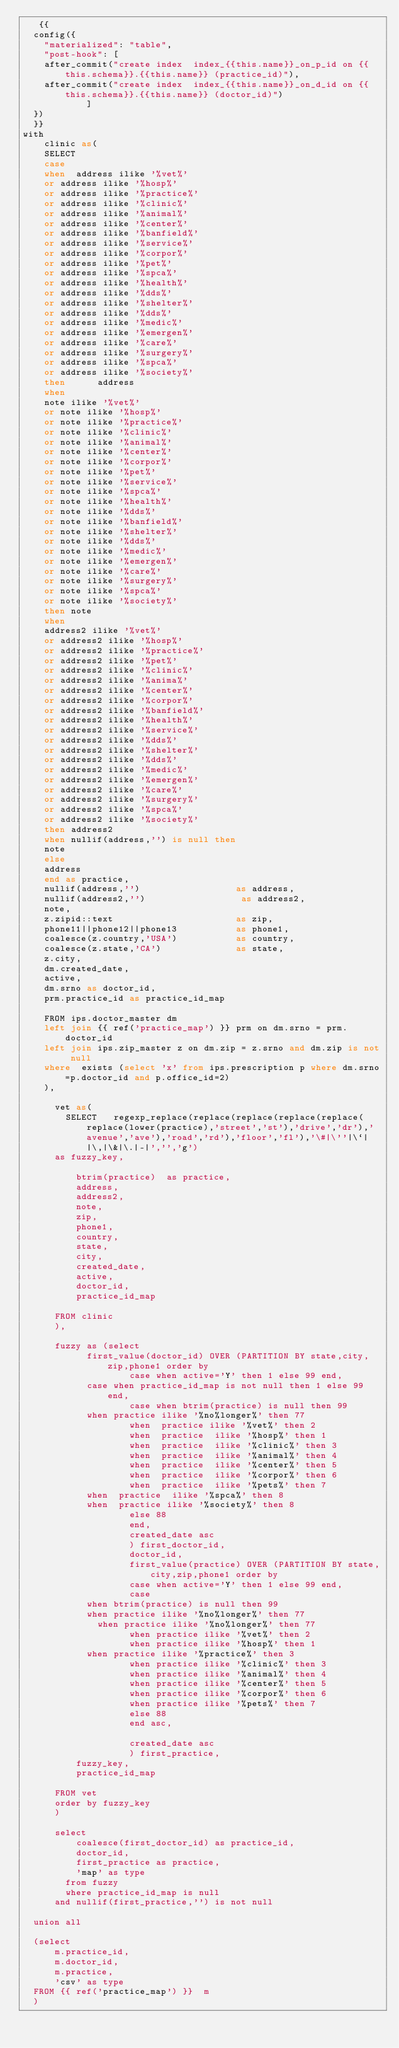Convert code to text. <code><loc_0><loc_0><loc_500><loc_500><_SQL_>   {{
  config({
    "materialized": "table",
    "post-hook": [
    after_commit("create index  index_{{this.name}}_on_p_id on {{this.schema}}.{{this.name}} (practice_id)"),
    after_commit("create index  index_{{this.name}}_on_d_id on {{this.schema}}.{{this.name}} (doctor_id)")
            ]
  })
  }}
with
    clinic as( 
    SELECT 
    case 
    when  address ilike '%vet%'
    or address ilike '%hosp%' 
    or address ilike '%practice%' 
    or address ilike '%clinic%' 
    or address ilike '%animal%'
    or address ilike '%center%' 
    or address ilike '%banfield%' 
    or address ilike '%service%' 
    or address ilike '%corpor%' 
    or address ilike '%pet%' 
    or address ilike '%spca%' 
    or address ilike '%health%' 
    or address ilike '%dds%' 
    or address ilike '%shelter%' 
    or address ilike '%dds%' 
    or address ilike '%medic%' 
    or address ilike '%emergen%' 
    or address ilike '%care%' 
    or address ilike '%surgery%' 
    or address ilike '%spca%' 
    or address ilike '%society%' 
    then      address
    when 		   
    note ilike '%vet%'
    or note ilike '%hosp%' 
    or note ilike '%practice%' 
    or note ilike '%clinic%' 
    or note ilike '%animal%'
    or note ilike '%center%' 
    or note ilike '%corpor%' 
    or note ilike '%pet%' 
    or note ilike '%service%' 
    or note ilike '%spca%' 	  
    or note ilike '%health%' 
    or note ilike '%dds%' 
    or note ilike '%banfield%' 
    or note ilike '%shelter%' 
    or note ilike '%dds%' 
    or note ilike '%medic%' 
    or note ilike '%emergen%' 
    or note ilike '%care%' 
    or note ilike '%surgery%' 
    or note ilike '%spca%' 
    or note ilike '%society%' 
    then note
    when 
    address2 ilike '%vet%'
    or address2 ilike '%hosp%' 
    or address2 ilike '%practice%' 
    or address2 ilike '%pet%' 
    or address2 ilike '%clinic%' 
    or address2 ilike '%anima%'
    or address2 ilike '%center%' 
    or address2 ilike '%corpor%' 
    or address2 ilike '%banfield%' 
    or address2 ilike '%health%' 
    or address2 ilike '%service%' 
    or address2 ilike '%dds%' 
    or address2 ilike '%shelter%' 
    or address2 ilike '%dds%' 
    or address2 ilike '%medic%' 
    or address2 ilike '%emergen%' 
    or address2 ilike '%care%' 
    or address2 ilike '%surgery%' 
    or address2 ilike '%spca%' 
    or address2 ilike '%society%' 
    then address2
    when nullif(address,'') is null then
    note
    else
    address
    end as practice,
    nullif(address,'')                  as address,
    nullif(address2,'')                  as address2,
    note,
    z.zipid::text                       as zip,
    phone11||phone12||phone13           as phone1,
    coalesce(z.country,'USA')           as country,
    coalesce(z.state,'CA')              as state,
    z.city,
    dm.created_date,
    active,
    dm.srno as doctor_id,
    prm.practice_id as practice_id_map

    FROM ips.doctor_master dm
    left join {{ ref('practice_map') }} prm on dm.srno = prm.doctor_id
    left join ips.zip_master z on dm.zip = z.srno and dm.zip is not null
    where  exists (select 'x' from ips.prescription p where dm.srno=p.doctor_id and p.office_id=2)
    ), 

      vet as(
        SELECT   regexp_replace(replace(replace(replace(replace(replace(lower(practice),'street','st'),'drive','dr'),'avenue','ave'),'road','rd'),'floor','fl'),'\#|\''|\`| |\,|\&|\.|-|','','g')
      as fuzzy_key,   

          btrim(practice)  as practice,
          address,
          address2,
          note,
          zip,
          phone1,
          country,
          state,
          city,
          created_date,
          active,
          doctor_id,	   
          practice_id_map

      FROM clinic
      ),
      
      fuzzy as (select 
            first_value(doctor_id) OVER (PARTITION BY state,city,zip,phone1 order by 
                    case when active='Y' then 1 else 99 end,   
            case when practice_id_map is not null then 1 else 99 end,
                    case when btrim(practice) is null then 99
            when practice ilike '%no%longer%' then 77
                    when  practice ilike '%vet%' then 2
                    when  practice  ilike '%hosp%' then 1 
                    when  practice  ilike '%clinic%' then 3
                    when  practice  ilike '%animal%' then 4
                    when  practice  ilike '%center%' then 5
                    when  practice  ilike '%corpor%' then 6
                    when  practice  ilike '%pets%' then 7
            when  practice  ilike '%spca%' then 8
            when  practice ilike '%society%' then 8
                    else 88
                    end,             
                    created_date asc               
                    ) first_doctor_id,	
                    doctor_id,
                    first_value(practice) OVER (PARTITION BY state,city,zip,phone1 order by 
                    case when active='Y' then 1 else 99 end,
                    case 
            when btrim(practice) is null then 99
            when practice ilike '%no%longer%' then 77
              when practice ilike '%no%longer%' then 77
                    when practice ilike '%vet%' then 2
                    when practice ilike '%hosp%' then 1 
            when practice ilike '%practice%' then 3 
                    when practice ilike '%clinic%' then 3
                    when practice ilike '%animal%' then 4
                    when practice ilike '%center%' then 5
                    when practice ilike '%corpor%' then 6
                    when practice ilike '%pets%' then 7
                    else 88
                    end asc,											
                    created_date asc
                    ) first_practice,
          fuzzy_key,
          practice_id_map
    
      FROM vet
      order by fuzzy_key
      )

      select     
          coalesce(first_doctor_id) as practice_id,
          doctor_id,
          first_practice as practice,
          'map' as type        
        from fuzzy 
        where practice_id_map is null
      and nullif(first_practice,'') is not null

  union all

  (select   
      m.practice_id,	
      m.doctor_id,
      m.practice,
      'csv' as type
  FROM {{ ref('practice_map') }}  m
  )</code> 